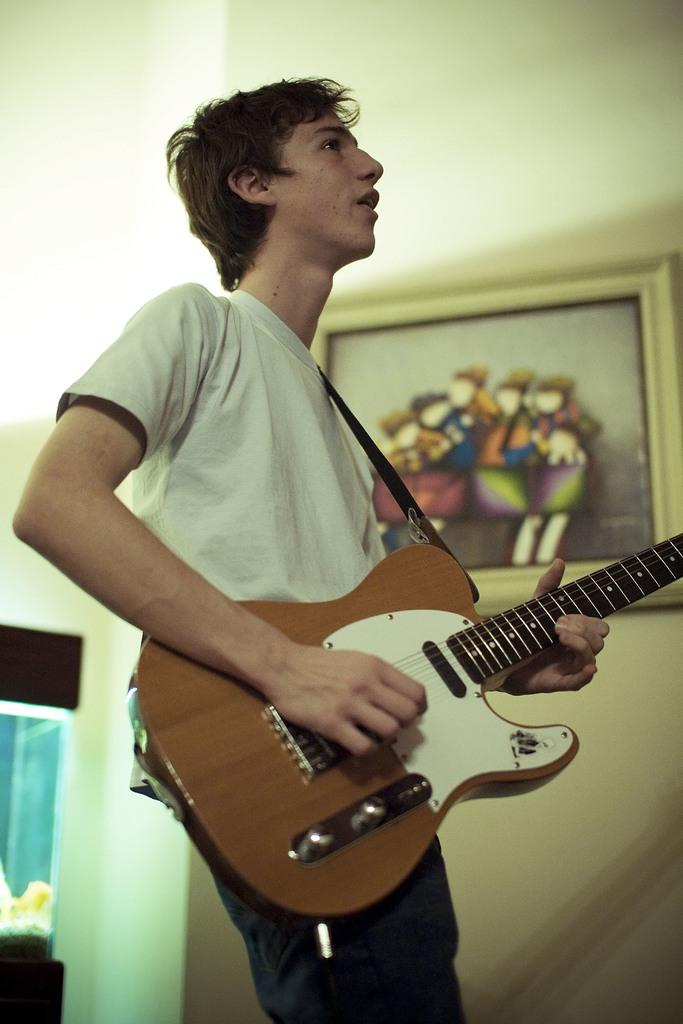Who is the person in the image? There is a man in the image. What is the man wearing? The man is wearing a white t-shirt. What is the man doing in the image? The man is playing a guitar. What can be seen on the wall in the image? There is a picture on the wall in the image. What other object is present in the image? There is an aquarium in the image. What type of grape is the man eating in the image? There is no grape present in the image, and the man is playing a guitar, not eating. 